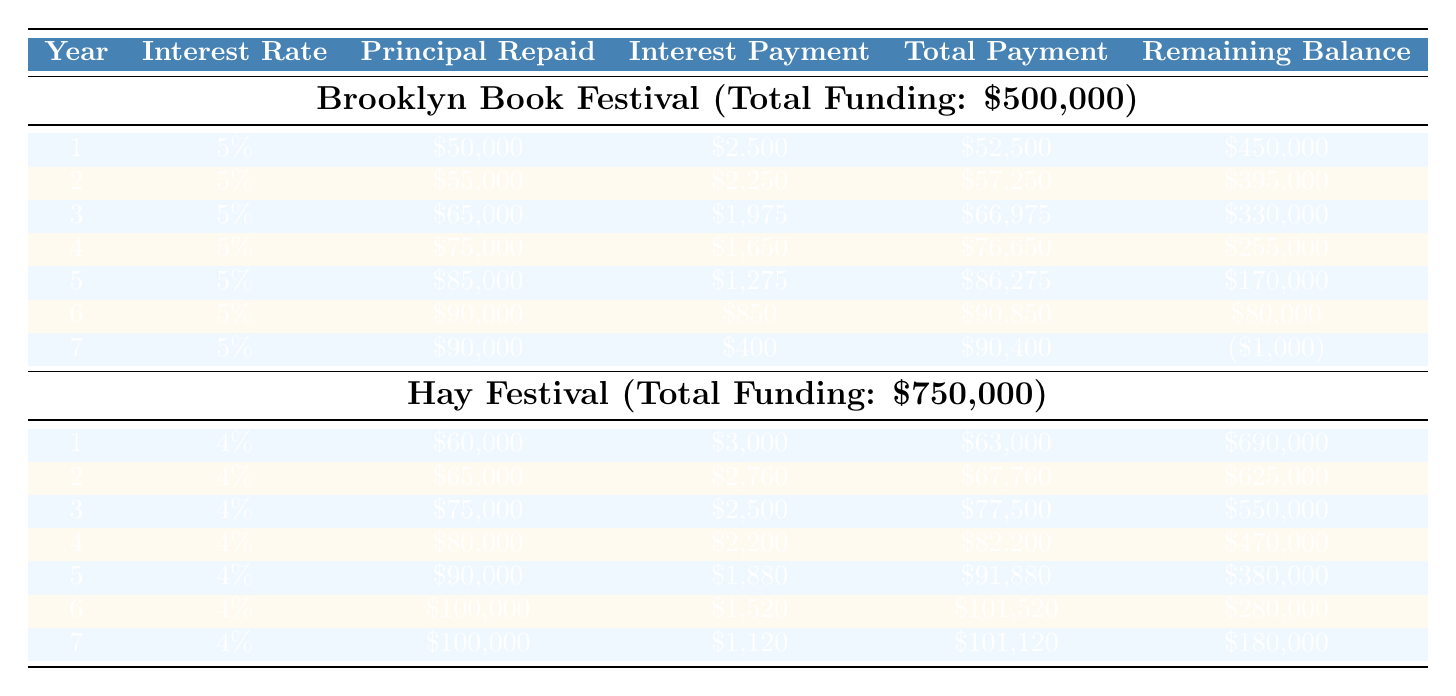What is the total funding for the Brooklyn Book Festival? The table clearly states that the total funding for the Brooklyn Book Festival is listed as $500,000.
Answer: 500000 In which year was the highest principal repaid for the Hay Festival? By examining the principal repaid column for the Hay Festival, the highest value of $100,000 occurs in both years 6 and 7.
Answer: 6 and 7 What was the total payment in Year 4 for the Brooklyn Book Festival? The table shows that the total payment for Year 4 of the Brooklyn Book Festival is $76,650, as indicated in the total payment column.
Answer: 76650 Does the Brooklyn Book Festival pay more in principal than interest in Year 3? In Year 3, the principal repaid is $65,000 while the interest payment is $1,975. Since $65,000 is greater than $1,975, the answer is yes.
Answer: Yes What is the average total payment made to the Hay Festival over the seven years? The total payments over the seven years sum up to $63000 + $67760 + $77500 + $82200 + $91880 + $101520 + $101120 = $672980. Dividing by 7 gives an average of $672980 / 7 = $96051.43.
Answer: 96051.43 In which year does the remaining balance become negative for the Brooklyn Book Festival? Looking through the remaining balance for each year of the Brooklyn Book Festival, the balance turns negative in Year 7, when it reaches -$1,000.
Answer: Year 7 What is the total interest payment made in Year 2 for the Hay Festival? According to the table, the interest payment for Year 2 of the Hay Festival is recorded as $2,760, clearly stated in the interest payment column.
Answer: 2760 Which festival has a higher total payment in Year 5, Brooklyn Book Festival or Hay Festival? The total payment in Year 5 for the Brooklyn Book Festival is $86,275, and for the Hay Festival, it is $91,880. Since $91,880 is greater than $86,275, the Hay Festival has a higher total payment in Year 5.
Answer: Hay Festival What is the difference in total principal repaid between the two festivals over seven years? Summing the principal repaid for the Brooklyn Book Festival yields $50,000 + $55,000 + $65,000 + $75,000 + $85,000 + $90,000 + $90,000 = $410,000. For the Hay Festival, it's $60,000 + $65,000 + $75,000 + $80,000 + $90,000 + $100,000 + $100,000 = $570,000. Therefore, the difference is $570,000 - $410,000 = $160,000.
Answer: 160000 